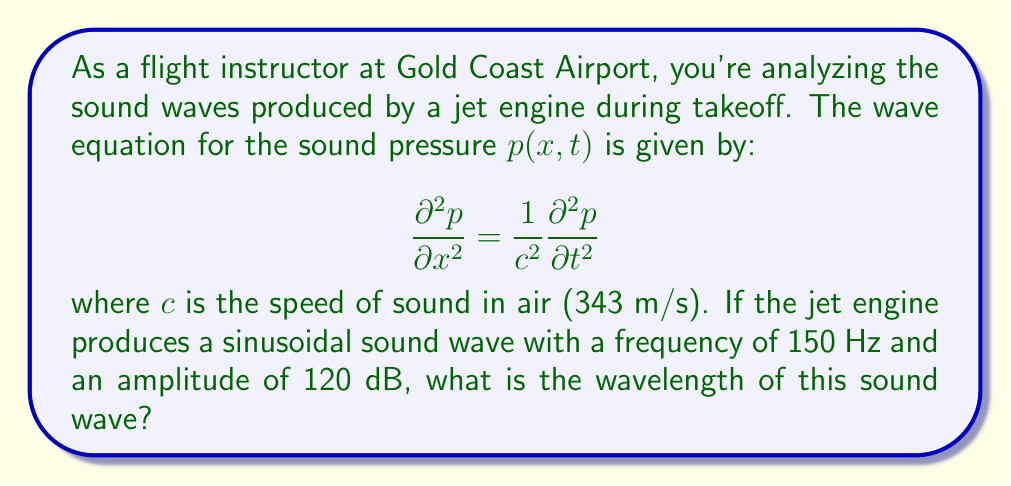Give your solution to this math problem. To solve this problem, we'll follow these steps:

1) First, recall the relationship between wavelength ($\lambda$), frequency ($f$), and wave speed ($c$):

   $$c = f\lambda$$

2) We're given the frequency $f = 150$ Hz and the speed of sound $c = 343$ m/s.

3) Rearranging the equation to solve for wavelength:

   $$\lambda = \frac{c}{f}$$

4) Now, let's substitute the known values:

   $$\lambda = \frac{343 \text{ m/s}}{150 \text{ Hz}}$$

5) Simplify:

   $$\lambda = 2.2867 \text{ m}$$

6) Rounding to two decimal places:

   $$\lambda \approx 2.29 \text{ m}$$

Note: The amplitude (120 dB) is not needed for this calculation, but it gives context to the intensity of the sound, which is relevant for considering the impact on nearby structures.
Answer: 2.29 m 